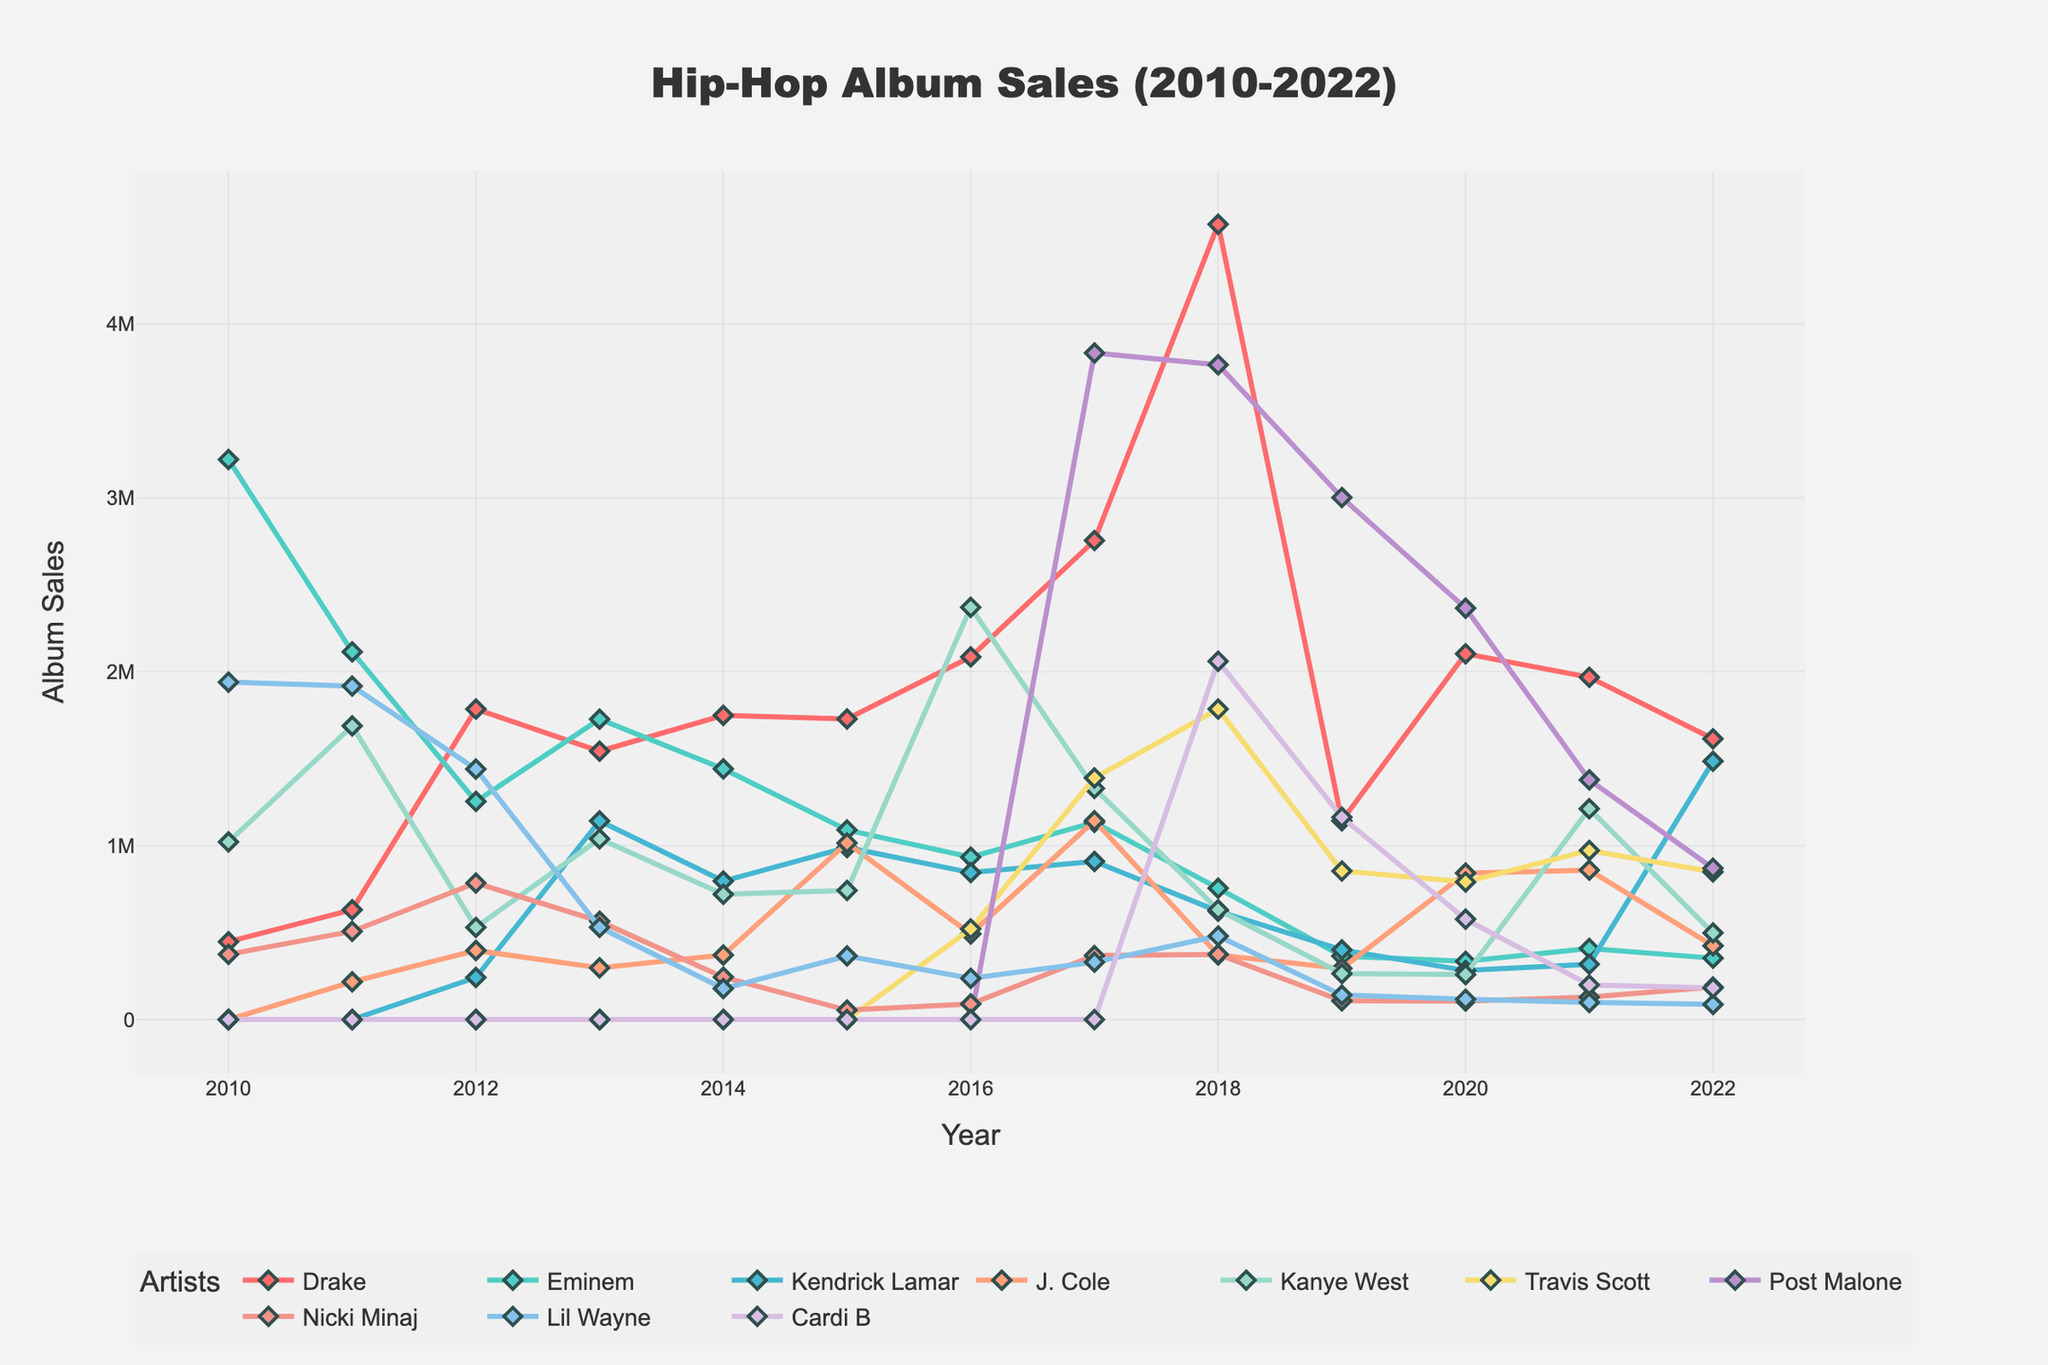What's the highest peak in album sales for any artist shown on the chart? To find the highest peak, scan the chart for the highest point of any line. This point corresponds to Drake's sales in 2018.
Answer: 4,572,000 Which artist's sales showed the most consistent decline from 2010 to 2022? To determine the most consistent decline, observe the overall trend for each artist. Eminem's sales have a generally downward trajectory without significant fluctuations.
Answer: Eminem Between Kendrick Lamar and Post Malone, who had higher sales in 2019? Compare the data points for Kendrick Lamar and Post Malone in 2019. Kendrick Lamar had 401,000 while Post Malone had 3,001,000.
Answer: Post Malone What was the total sales difference between Travis Scott and Cardi B in 2018? Find the 2018 sales for Travis Scott and Cardi B: 1,785,000 and 2,060,000 respectively. Calculate their difference: 2,060,000 - 1,785,000 = 275,000.
Answer: 275,000 Which artist had the highest sales in 2022? Look at the data points for 2022 and identify the highest value. Kendrick Lamar's sales were 1,485,000, the highest among all.
Answer: Kendrick Lamar From 2010 to 2022, which artist had the least variable (most stable) sales trend? Look for an artist whose sales line is the least erratic over the years. Drake’s sales fluctuate but stay high, showing general consistency.
Answer: Drake What was the average sales for Nicki Minaj from 2010 to 2022? Sum Nicki Minaj's sales from 2010 to 2022 (375000 + 507000 + 785000 + 565000 + 244000 + 54000 + 90000 + 368000 + 375000 + 108000 + 106000 + 129000 + 187000) = 3511000. Then divide by the number of years (13). 3511000 / 13 ≈ 270,077.
Answer: 270,077 Which artist experienced the largest drop in sales from their highest point to their lowest point? Identify the high and low points for each artist, then calculate the drop. Post Malone peaked at 3,832,000 in 2017 and dropped to 870,000 in 2022, a difference of 2,962,000.
Answer: Post Malone Between J. Cole and Kanye West, who had a better sales performance in 2016? Compare the 2016 sales for J. Cole (492,000) and Kanye West (2,370,000).
Answer: Kanye West How many artists had a peak in their sales during 2017? Count the number of artists whose sales peaked in 2017 by comparing their respective highest sales across all years. Drake, J. Cole, and Travis Scott had peaks in 2017.
Answer: 3 